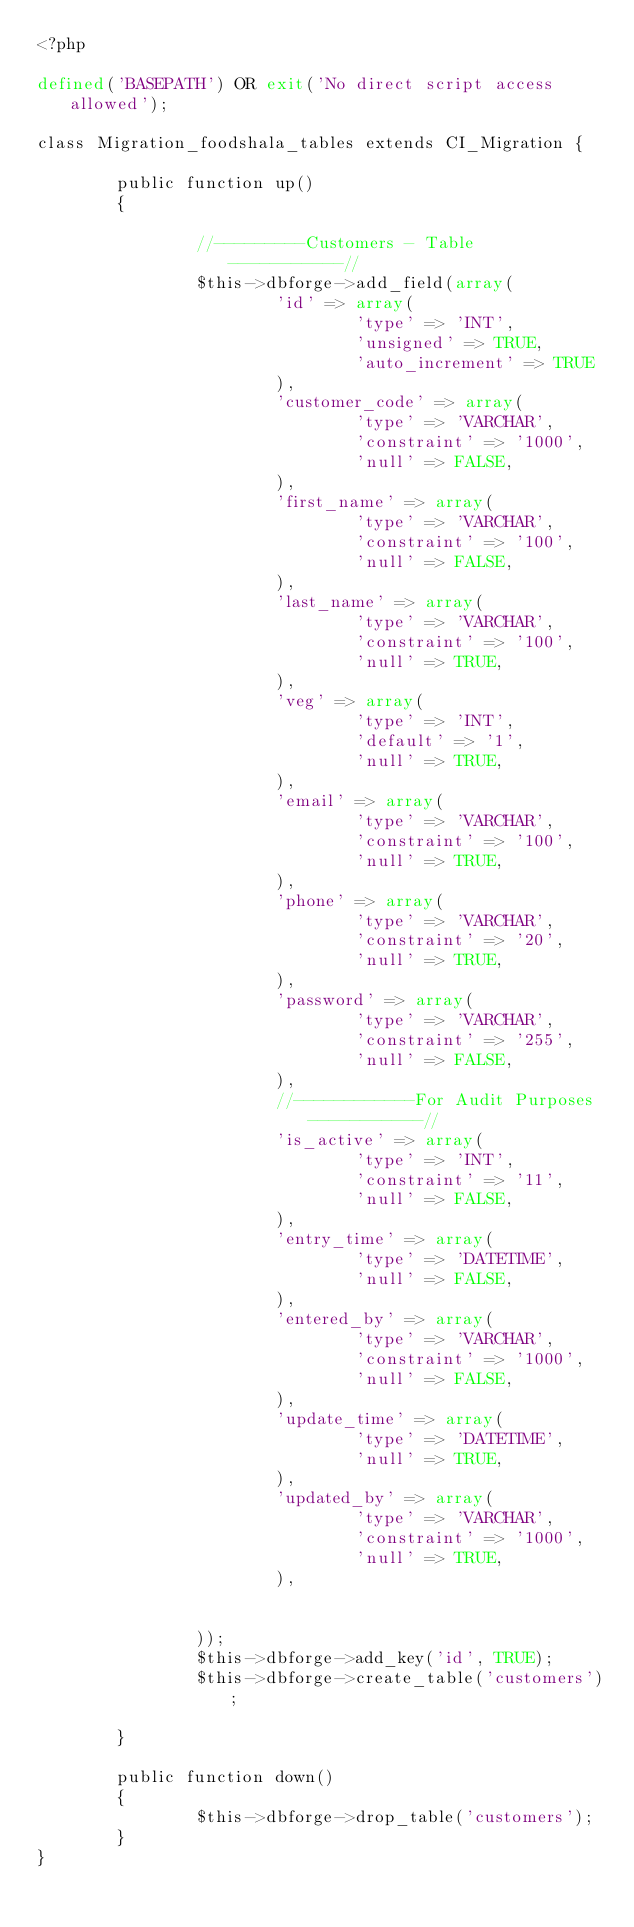Convert code to text. <code><loc_0><loc_0><loc_500><loc_500><_PHP_><?php

defined('BASEPATH') OR exit('No direct script access allowed');

class Migration_foodshala_tables extends CI_Migration {

        public function up()
        {
                
                //---------Customers - Table -----------//
                $this->dbforge->add_field(array(
                        'id' => array(
                                'type' => 'INT',
                                'unsigned' => TRUE,
                                'auto_increment' => TRUE
                        ),
                        'customer_code' => array(
                                'type' => 'VARCHAR',
                                'constraint' => '1000',
                                'null' => FALSE,
                        ),
                        'first_name' => array(
                                'type' => 'VARCHAR',
                                'constraint' => '100',
                                'null' => FALSE,
                        ),
                        'last_name' => array(
                                'type' => 'VARCHAR',
                                'constraint' => '100',
                                'null' => TRUE,
                        ),
                        'veg' => array(
                                'type' => 'INT',
                                'default' => '1',
                                'null' => TRUE,
                        ),
                        'email' => array(
                                'type' => 'VARCHAR',
                                'constraint' => '100',
                                'null' => TRUE,
                        ),
                        'phone' => array(
                                'type' => 'VARCHAR',
                                'constraint' => '20',
                                'null' => TRUE,
                        ),
                        'password' => array(
                                'type' => 'VARCHAR',
                                'constraint' => '255',
                                'null' => FALSE,
                        ),
                        //------------For Audit Purposes -----------//
                        'is_active' => array(
                                'type' => 'INT',
                                'constraint' => '11',
                                'null' => FALSE,
                        ),
                        'entry_time' => array(
                                'type' => 'DATETIME',
                                'null' => FALSE,
                        ),
                        'entered_by' => array(
                                'type' => 'VARCHAR',
                                'constraint' => '1000',
                                'null' => FALSE,
                        ),
                        'update_time' => array(
                                'type' => 'DATETIME',
                                'null' => TRUE,
                        ),
                        'updated_by' => array(
                                'type' => 'VARCHAR',
                                'constraint' => '1000',
                                'null' => TRUE,
                        ),
                        
                        
                ));
                $this->dbforge->add_key('id', TRUE);
                $this->dbforge->create_table('customers');

        }

        public function down()
        {
                $this->dbforge->drop_table('customers');
        }
}</code> 